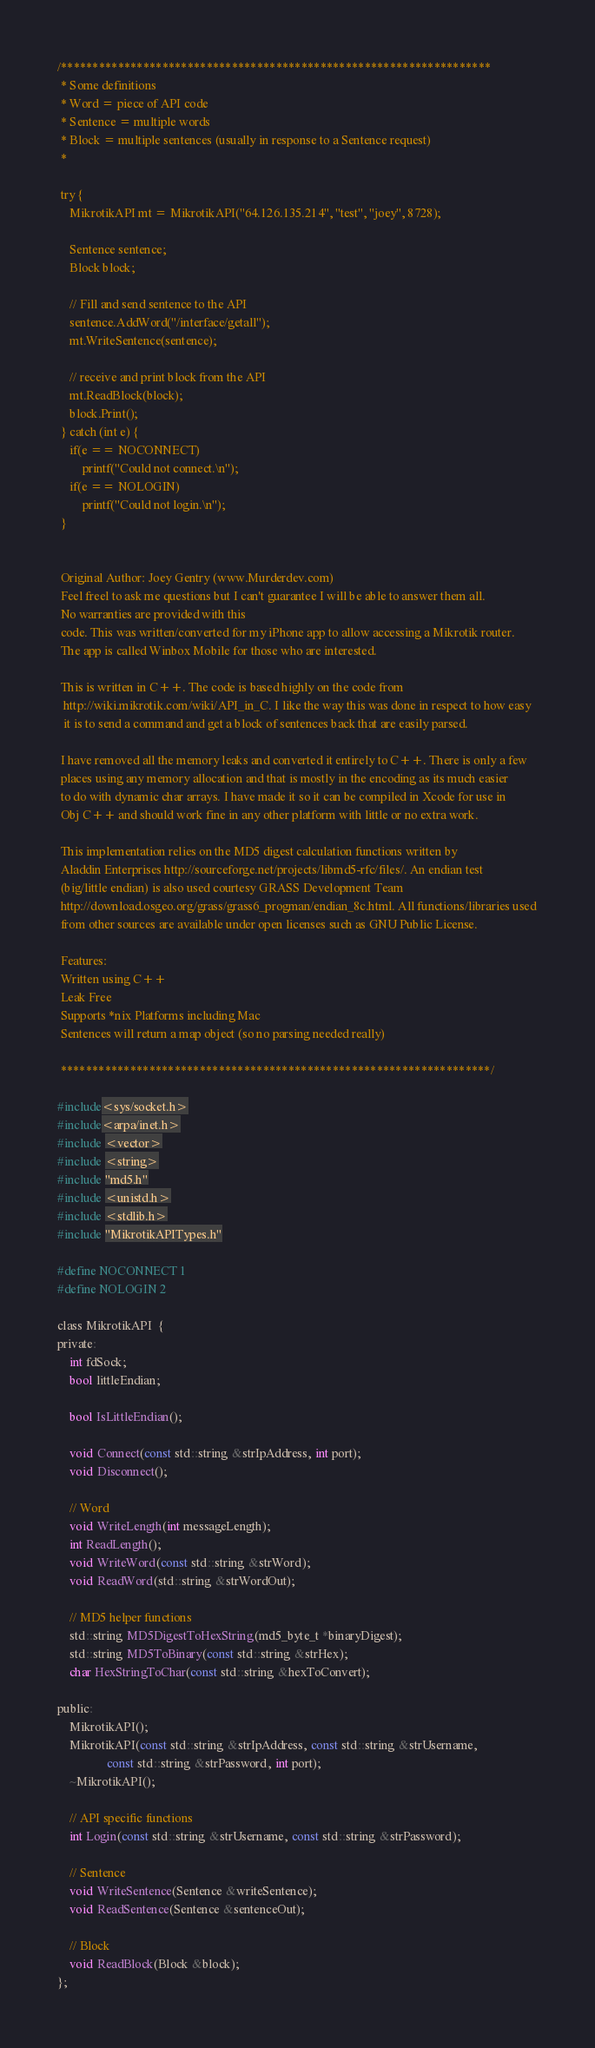Convert code to text. <code><loc_0><loc_0><loc_500><loc_500><_C_>/********************************************************************
 * Some definitions
 * Word = piece of API code
 * Sentence = multiple words
 * Block = multiple sentences (usually in response to a Sentence request)
 *

 try {
	MikrotikAPI mt = MikrotikAPI("64.126.135.214", "test", "joey", 8728);

	Sentence sentence;
	Block block;

	// Fill and send sentence to the API
	sentence.AddWord("/interface/getall");
	mt.WriteSentence(sentence);

	// receive and print block from the API
	mt.ReadBlock(block);
	block.Print();
 } catch (int e) {
	if(e == NOCONNECT)
		printf("Could not connect.\n");
	if(e == NOLOGIN)
		printf("Could not login.\n");
 }


 Original Author: Joey Gentry (www.Murderdev.com)
 Feel freel to ask me questions but I can't guarantee I will be able to answer them all.
 No warranties are provided with this
 code. This was written/converted for my iPhone app to allow accessing a Mikrotik router.
 The app is called Winbox Mobile for those who are interested.

 This is written in C++. The code is based highly on the code from
  http://wiki.mikrotik.com/wiki/API_in_C. I like the way this was done in respect to how easy
  it is to send a command and get a block of sentences back that are easily parsed.

 I have removed all the memory leaks and converted it entirely to C++. There is only a few
 places using any memory allocation and that is mostly in the encoding as its much easier
 to do with dynamic char arrays. I have made it so it can be compiled in Xcode for use in
 Obj C++ and should work fine in any other platform with little or no extra work.

 This implementation relies on the MD5 digest calculation functions written by
 Aladdin Enterprises http://sourceforge.net/projects/libmd5-rfc/files/. An endian test
 (big/little endian) is also used courtesy GRASS Development Team
 http://download.osgeo.org/grass/grass6_progman/endian_8c.html. All functions/libraries used
 from other sources are available under open licenses such as GNU Public License.

 Features:
 Written using C++
 Leak Free
 Supports *nix Platforms including Mac
 Sentences will return a map object (so no parsing needed really)

 ********************************************************************/

#include<sys/socket.h>
#include<arpa/inet.h>
#include <vector>
#include <string>
#include "md5.h"
#include <unistd.h>
#include <stdlib.h>
#include "MikrotikAPITypes.h"

#define NOCONNECT 1
#define NOLOGIN 2

class MikrotikAPI  {
private:
    int fdSock;
    bool littleEndian;

    bool IsLittleEndian();

    void Connect(const std::string &strIpAddress, int port);
    void Disconnect();

    // Word
    void WriteLength(int messageLength);
    int ReadLength();
    void WriteWord(const std::string &strWord);
    void ReadWord(std::string &strWordOut);

    // MD5 helper functions
    std::string MD5DigestToHexString(md5_byte_t *binaryDigest);
    std::string MD5ToBinary(const std::string &strHex);
    char HexStringToChar(const std::string &hexToConvert);

public:
    MikrotikAPI();
    MikrotikAPI(const std::string &strIpAddress, const std::string &strUsername,
                const std::string &strPassword, int port);
    ~MikrotikAPI();

    // API specific functions
    int Login(const std::string &strUsername, const std::string &strPassword);

    // Sentence
    void WriteSentence(Sentence &writeSentence);
    void ReadSentence(Sentence &sentenceOut);

    // Block
    void ReadBlock(Block &block);
};
</code> 